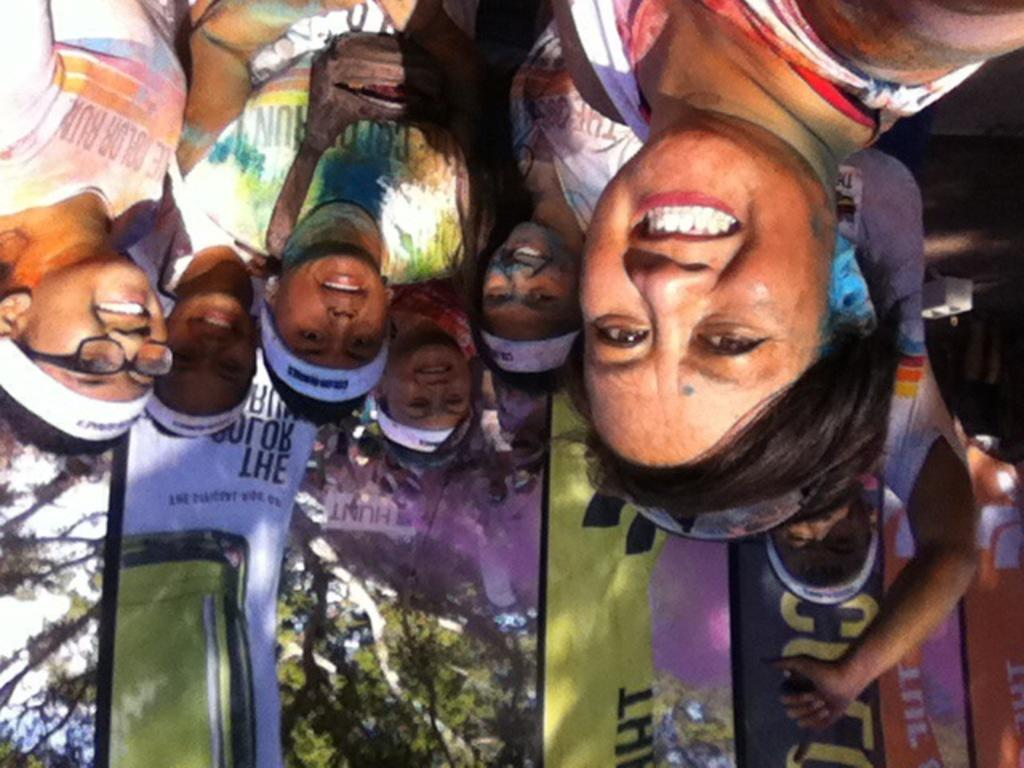What can be seen at the top of the image? There is a group of people at the top of the image. What are the people in the image doing? The group of people are watching something. What is present at the bottom of the image? There are banners and trees at the bottom of the image. How many lizards can be seen climbing on the banners in the image? There are no lizards present in the image; the banners are not being climbed on by any animals. 